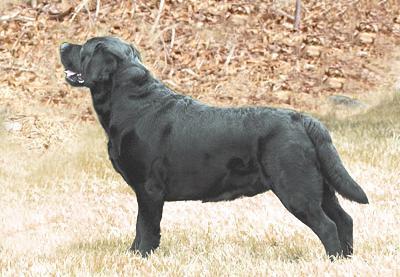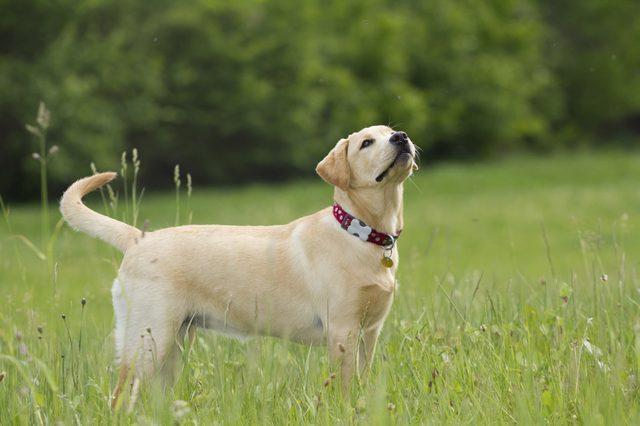The first image is the image on the left, the second image is the image on the right. Analyze the images presented: Is the assertion "The left image includes a royal blue leash and an adult white dog sitting upright on green grass." valid? Answer yes or no. No. The first image is the image on the left, the second image is the image on the right. For the images shown, is this caption "There is at least one dog wearing a leash" true? Answer yes or no. No. 